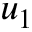<formula> <loc_0><loc_0><loc_500><loc_500>u _ { 1 }</formula> 